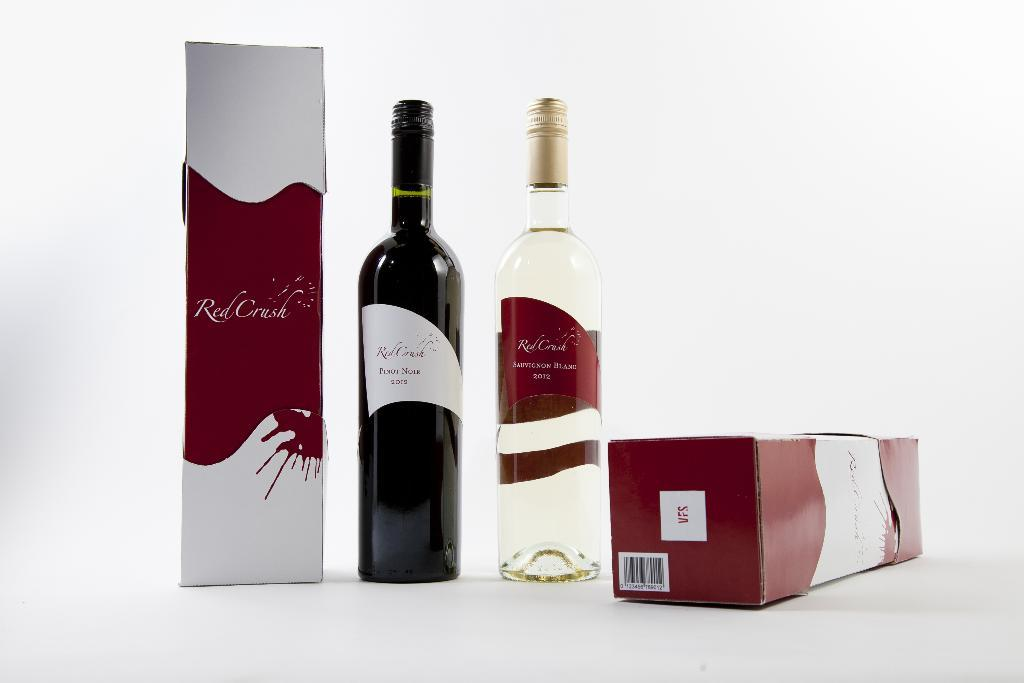<image>
Offer a succinct explanation of the picture presented. A bottle of Pinot Noir is next to a Sauvignon Blanc. 